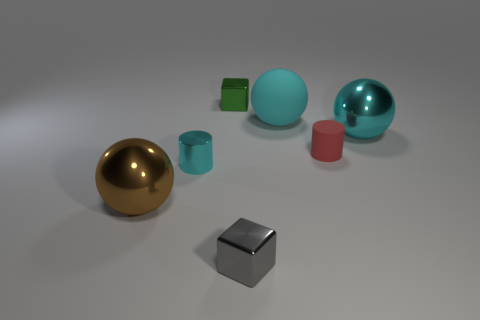What size is the cylinder that is behind the small cyan cylinder?
Offer a terse response. Small. Is there anything else of the same color as the metal cylinder?
Ensure brevity in your answer.  Yes. Are there any small blocks in front of the small block behind the cyan shiny object that is to the right of the matte ball?
Give a very brief answer. Yes. Is the color of the large shiny sphere that is behind the cyan cylinder the same as the big matte thing?
Your answer should be very brief. Yes. How many blocks are either small cyan metallic objects or small metal objects?
Your answer should be compact. 2. There is a small metal thing that is behind the small red matte object that is to the right of the small gray object; what shape is it?
Provide a short and direct response. Cube. There is a cyan thing in front of the cylinder that is to the right of the block that is in front of the small green metal block; what size is it?
Your response must be concise. Small. Does the gray thing have the same size as the cyan matte thing?
Your response must be concise. No. How many things are either tiny yellow cylinders or big cyan objects?
Provide a succinct answer. 2. How big is the cyan thing in front of the large cyan ball on the right side of the large cyan rubber object?
Offer a terse response. Small. 